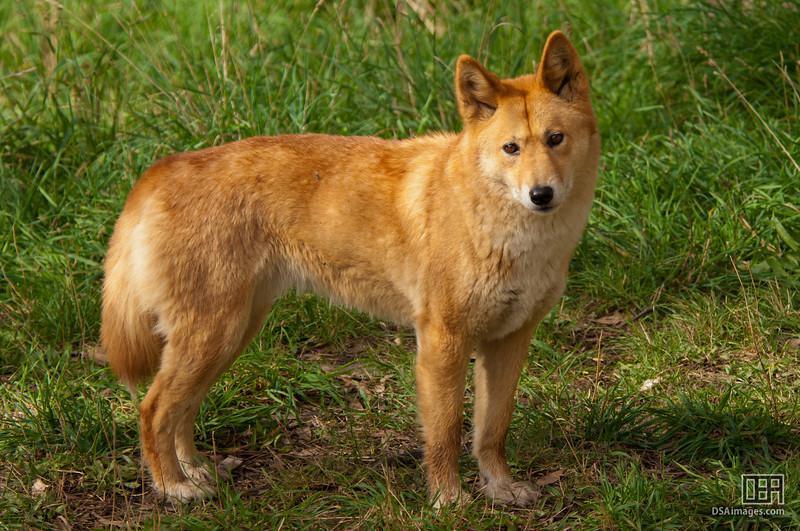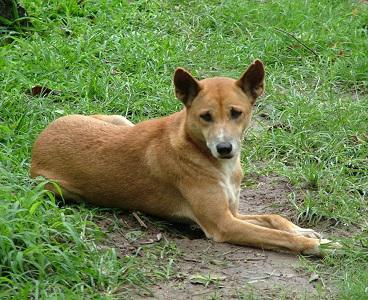The first image is the image on the left, the second image is the image on the right. Given the left and right images, does the statement "All dogs in the images are standing with all visible paws on the ground." hold true? Answer yes or no. No. 